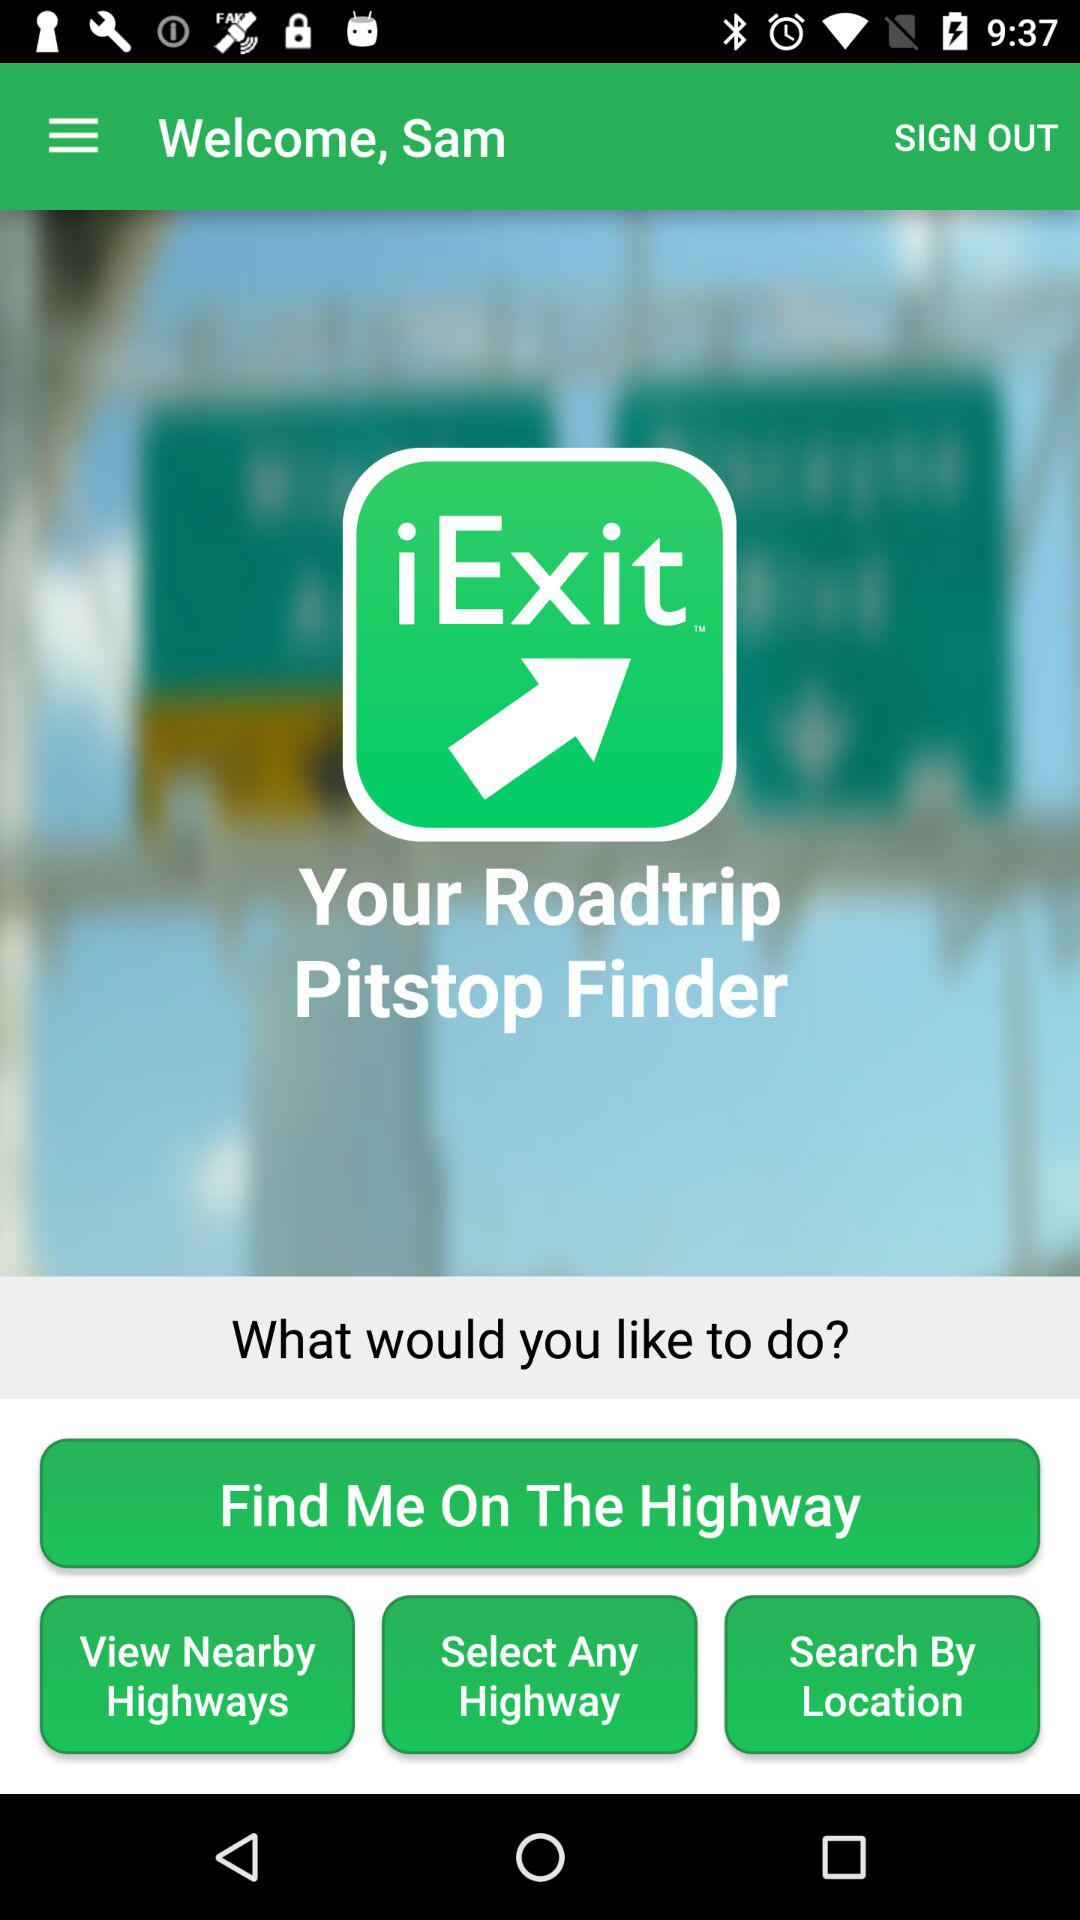What is the name of user? The user name is Sam. 